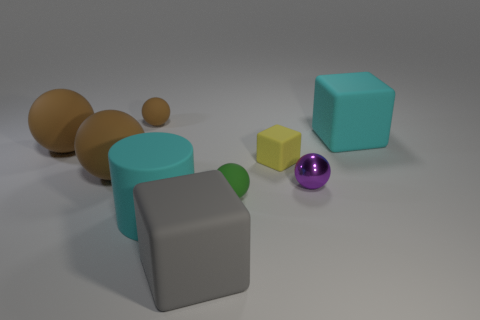Subtract all small metallic balls. How many balls are left? 4 Subtract all blue cubes. Subtract all blue cylinders. How many cubes are left? 3 Subtract all red spheres. How many yellow cubes are left? 1 Subtract all big green rubber balls. Subtract all large rubber objects. How many objects are left? 4 Add 4 large cyan objects. How many large cyan objects are left? 6 Add 2 big rubber spheres. How many big rubber spheres exist? 4 Add 1 brown cubes. How many objects exist? 10 Subtract all purple spheres. How many spheres are left? 4 Subtract 0 purple blocks. How many objects are left? 9 Subtract all cylinders. How many objects are left? 8 